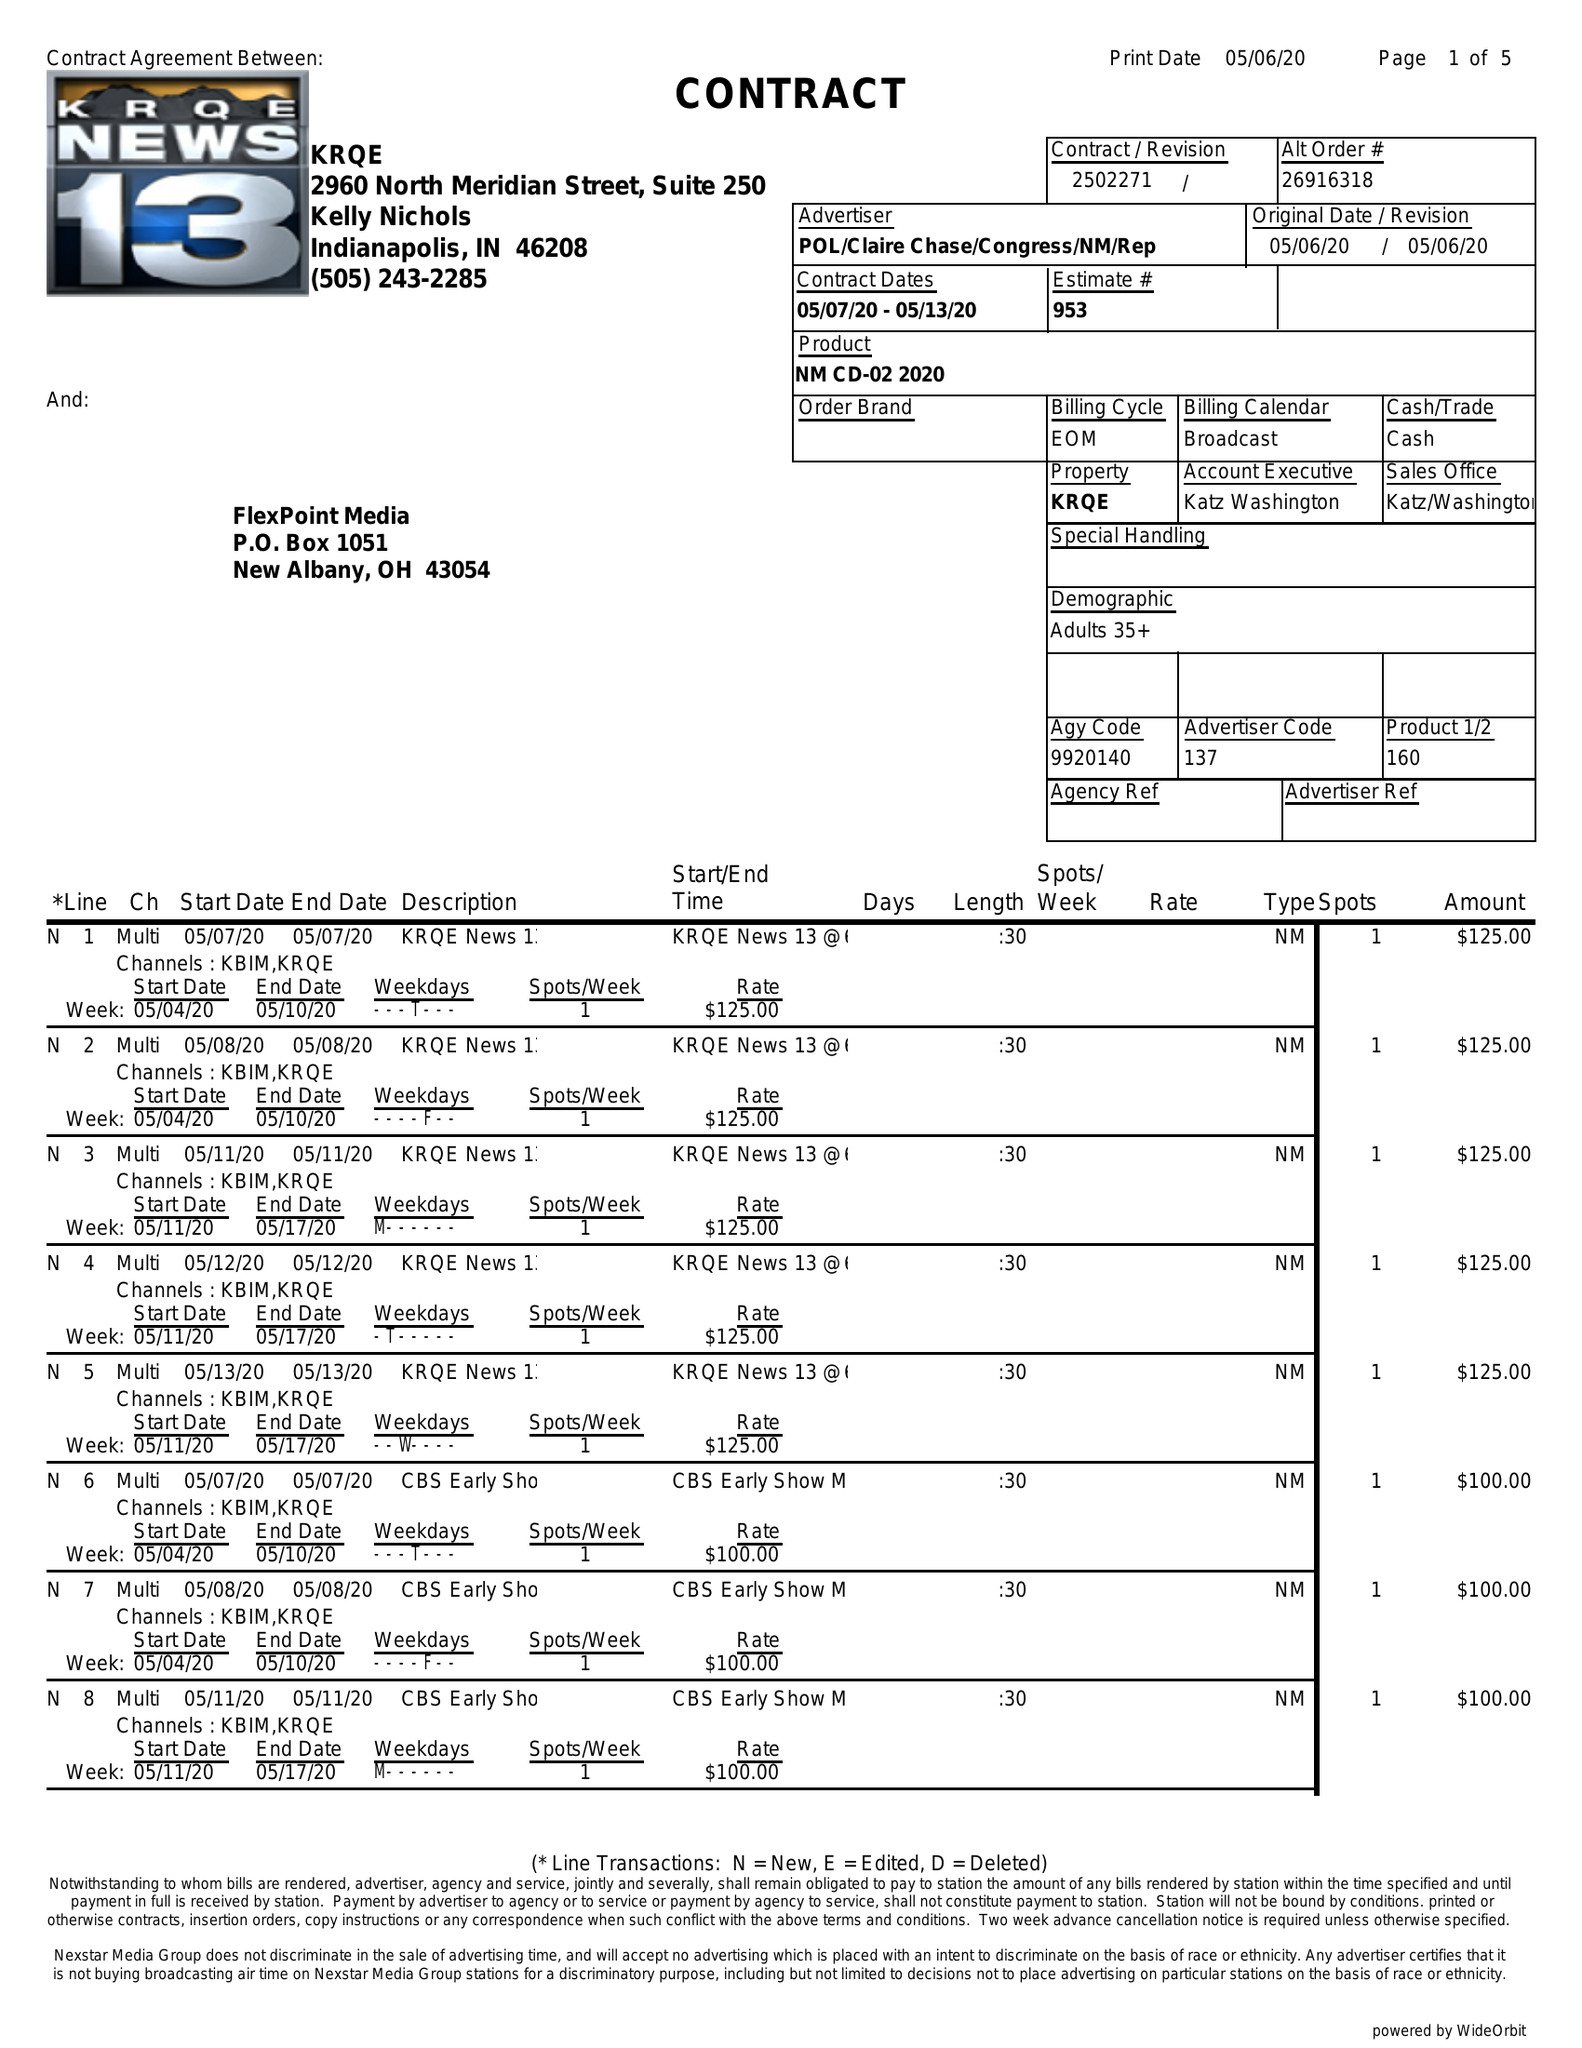What is the value for the gross_amount?
Answer the question using a single word or phrase. 11920.00 